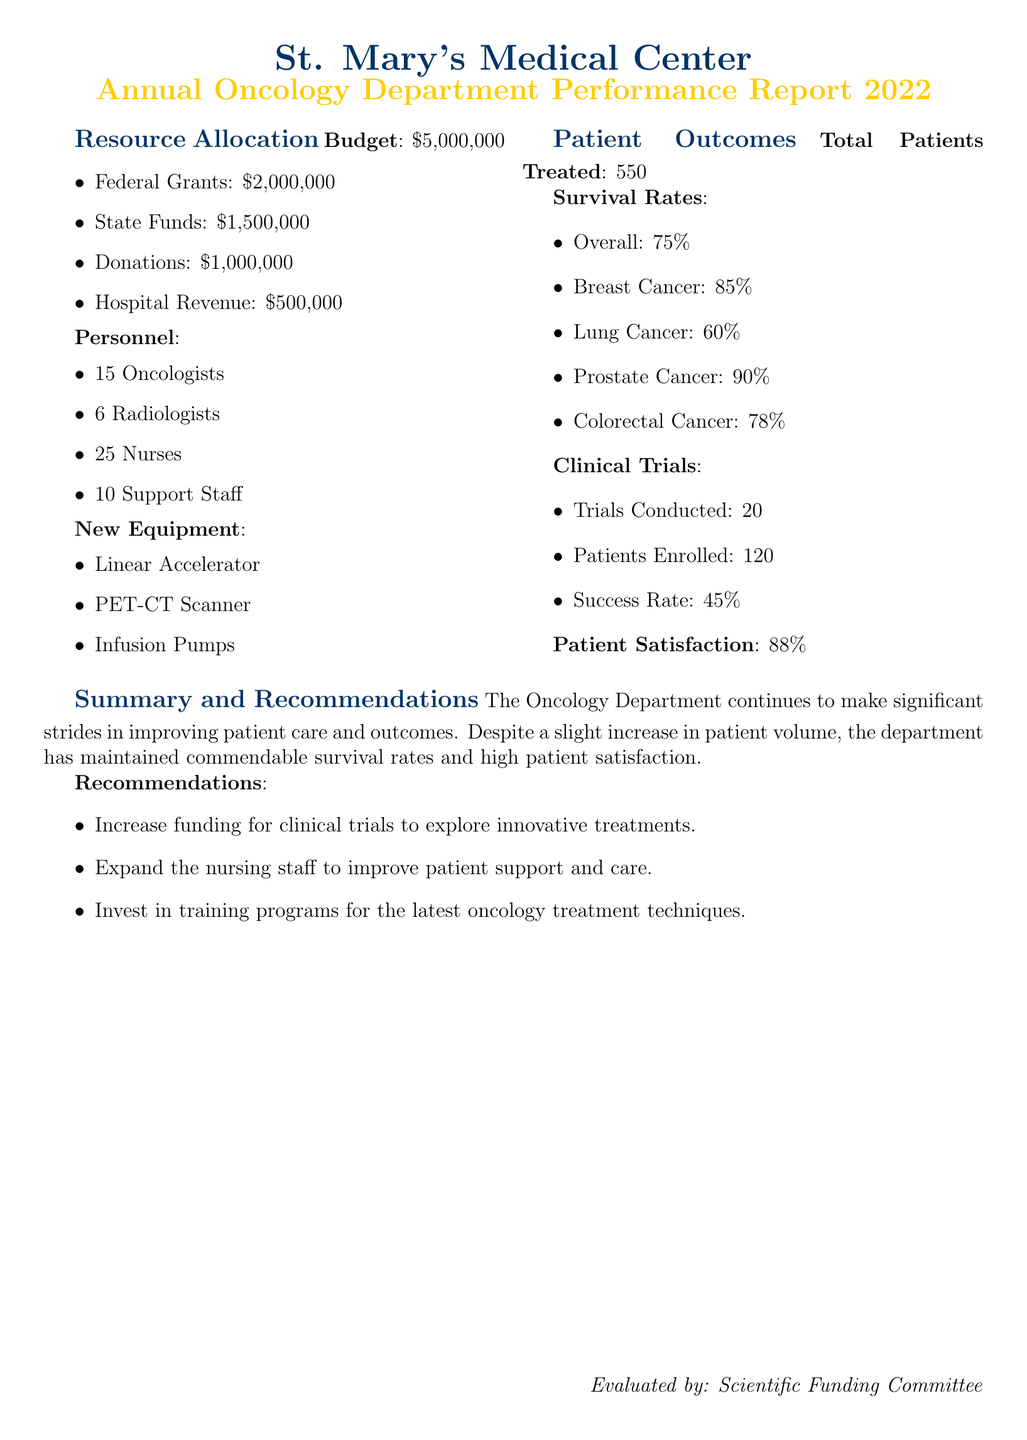What is the total budget for the oncology department? The budget is listed at the beginning of the resource allocation section, which is $5,000,000.
Answer: $5,000,000 How many oncologists are in the department? The personnel section specifies that there are 15 oncologists.
Answer: 15 What is the survival rate for breast cancer patients? The survival rates section provides the specific rate for breast cancer, which is 85%.
Answer: 85% How many clinical trials were conducted? The clinical trials section states that 20 trials were conducted.
Answer: 20 What percentage of patients reported satisfaction with the services? The patient satisfaction section mentions that 88% of patients are satisfied.
Answer: 88% What is the success rate of clinical trials? The clinical trials section specifies a success rate of 45%.
Answer: 45% What type of new equipment was acquired? The new equipment list includes items such as a Linear Accelerator, which indicates advancements in technology used.
Answer: Linear Accelerator What was the number of total patients treated in the oncology department? The document states that 550 patients were treated in total.
Answer: 550 What recommendation was made regarding nursing staff? One of the recommendations suggests expanding the nursing staff to improve patient care.
Answer: Expand the nursing staff 